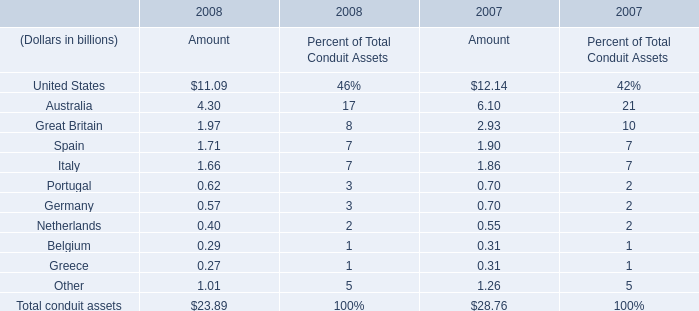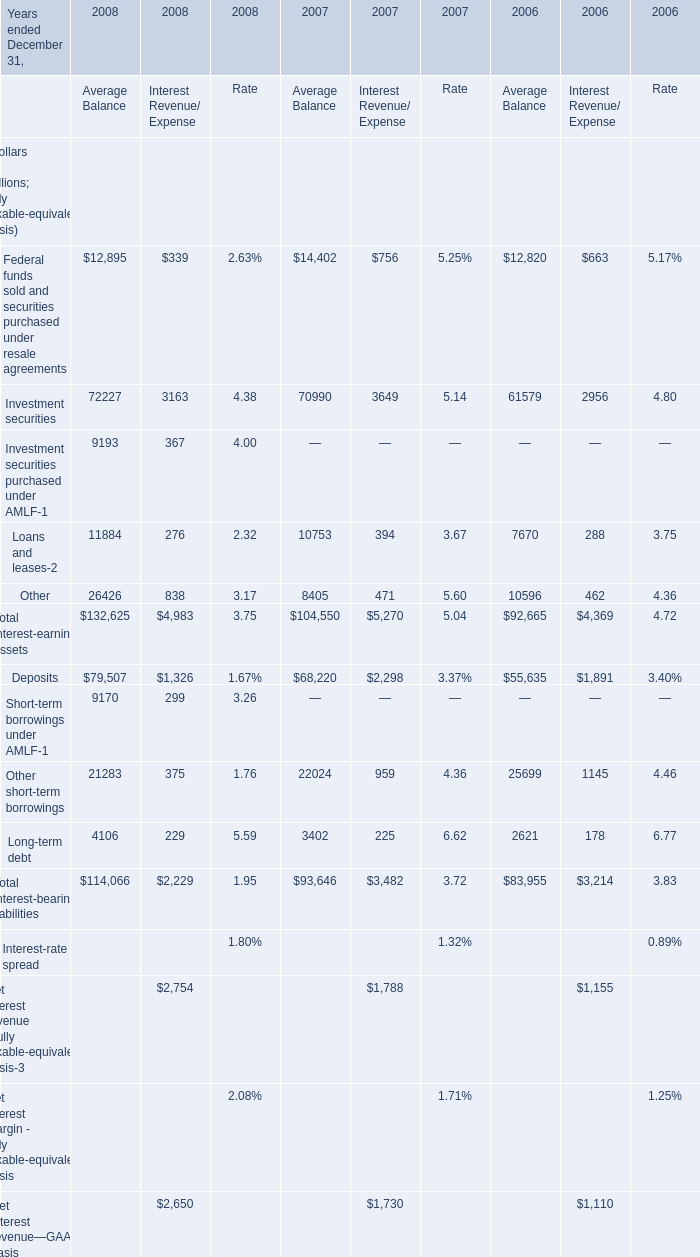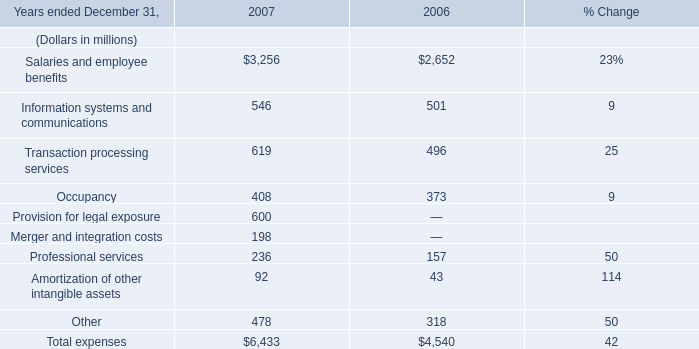What is the 50% of the Amount of the Total conduit assets that is greater than 28 billion as As the chart 0 shows? (in billion) 
Computations: (0.5 * 28.76)
Answer: 14.38. 